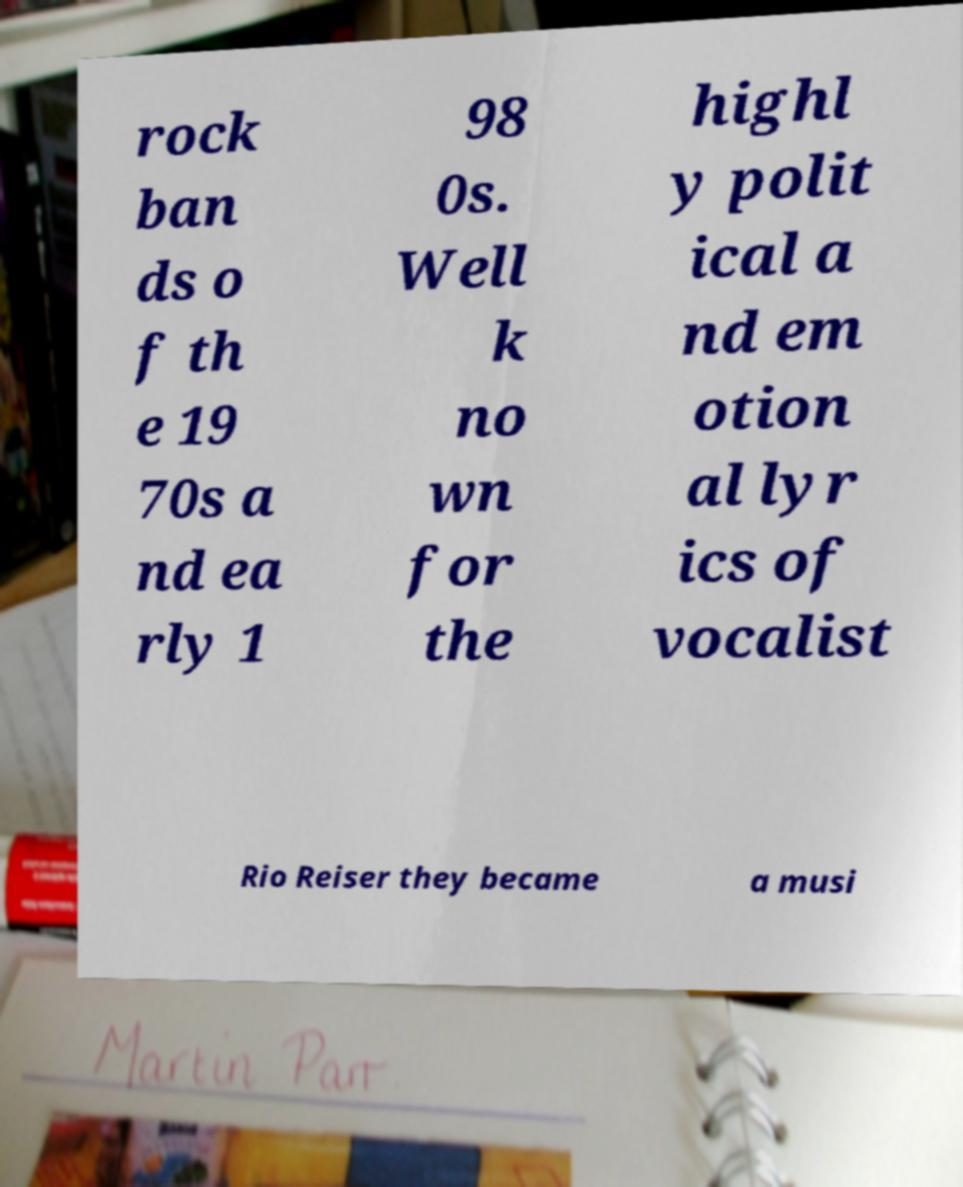Can you accurately transcribe the text from the provided image for me? rock ban ds o f th e 19 70s a nd ea rly 1 98 0s. Well k no wn for the highl y polit ical a nd em otion al lyr ics of vocalist Rio Reiser they became a musi 